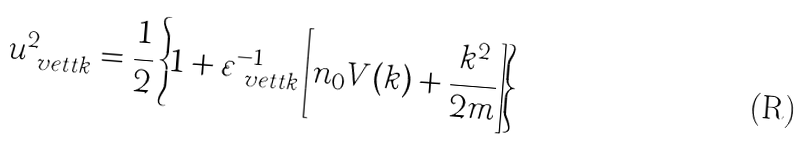<formula> <loc_0><loc_0><loc_500><loc_500>u _ { \ v e t t k } ^ { 2 } = \frac { 1 } { 2 } \left \{ 1 + \varepsilon _ { \ v e t t k } ^ { - 1 } \left [ n _ { 0 } V ( k ) + \frac { k ^ { 2 } } { 2 m } \right ] \right \}</formula> 